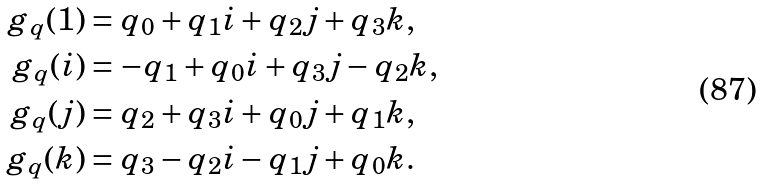Convert formula to latex. <formula><loc_0><loc_0><loc_500><loc_500>g _ { q } ( 1 ) & = q _ { 0 } + q _ { 1 } i + q _ { 2 } j + q _ { 3 } k , \\ g _ { q } ( i ) & = - q _ { 1 } + q _ { 0 } i + q _ { 3 } j - q _ { 2 } k , \\ g _ { q } ( j ) & = q _ { 2 } + q _ { 3 } i + q _ { 0 } j + q _ { 1 } k , \\ g _ { q } ( k ) & = q _ { 3 } - q _ { 2 } i - q _ { 1 } j + q _ { 0 } k .</formula> 